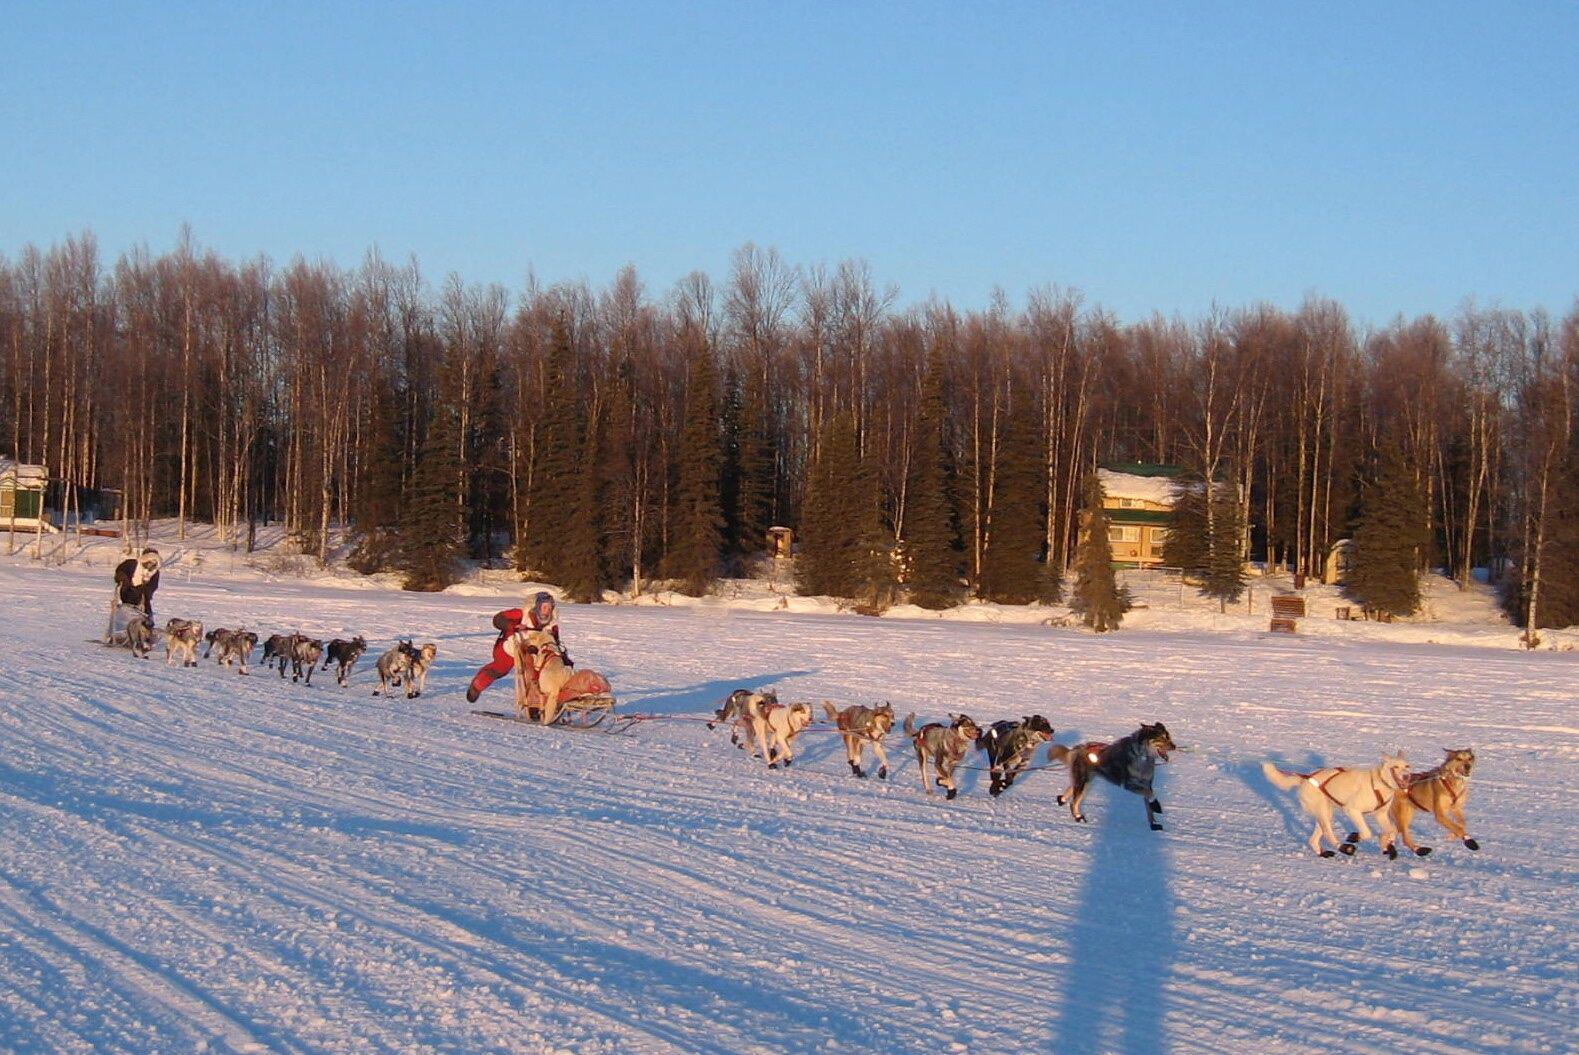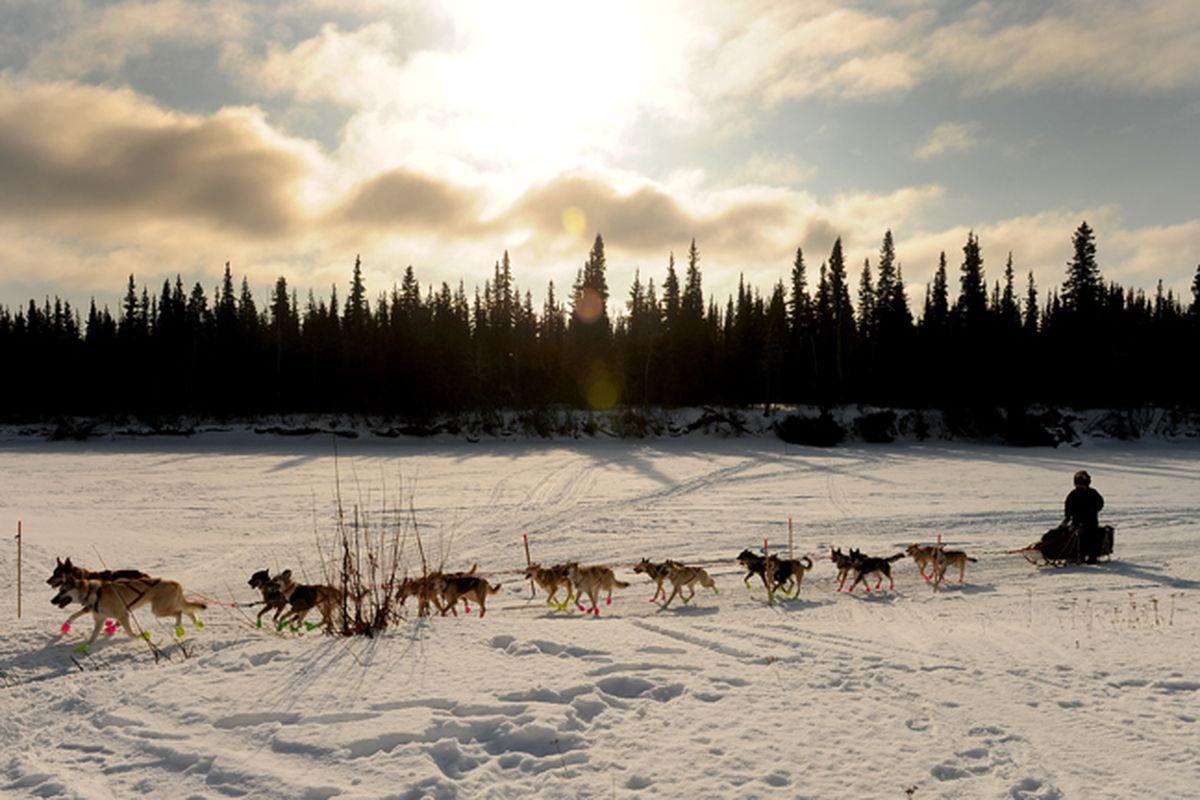The first image is the image on the left, the second image is the image on the right. Evaluate the accuracy of this statement regarding the images: "The sun gives off a soft glow behind the clouds in at least one of the images.". Is it true? Answer yes or no. Yes. The first image is the image on the left, the second image is the image on the right. Considering the images on both sides, is "Tall trees but no tall hills line the horizon in both images of sled dogs moving across the snow, and at least one image shows the sun shining above the trees." valid? Answer yes or no. Yes. 